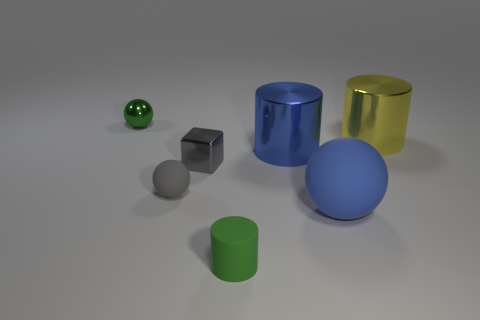Add 3 tiny gray rubber things. How many objects exist? 10 Subtract all cylinders. How many objects are left? 4 Add 3 yellow metallic cylinders. How many yellow metallic cylinders exist? 4 Subtract 0 red cylinders. How many objects are left? 7 Subtract all small gray things. Subtract all small green metallic balls. How many objects are left? 4 Add 3 tiny gray matte things. How many tiny gray matte things are left? 4 